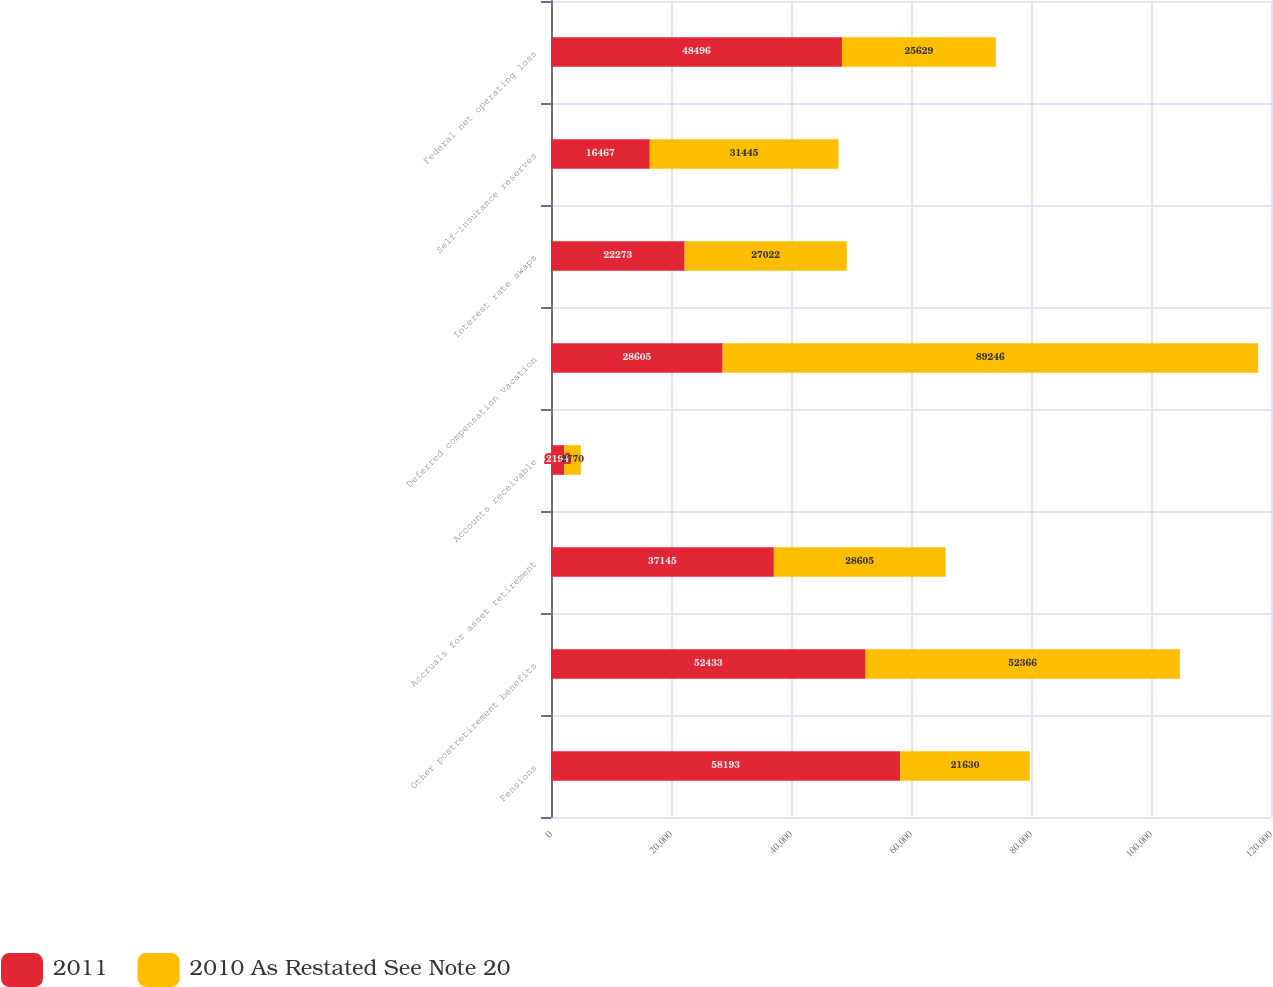<chart> <loc_0><loc_0><loc_500><loc_500><stacked_bar_chart><ecel><fcel>Pensions<fcel>Other postretirement benefits<fcel>Accruals for asset retirement<fcel>Accounts receivable<fcel>Deferred compensation vacation<fcel>Interest rate swaps<fcel>Self-insurance reserves<fcel>Federal net operating loss<nl><fcel>2011<fcel>58193<fcel>52433<fcel>37145<fcel>2194<fcel>28605<fcel>22273<fcel>16467<fcel>48496<nl><fcel>2010 As Restated See Note 20<fcel>21630<fcel>52366<fcel>28605<fcel>2770<fcel>89246<fcel>27022<fcel>31445<fcel>25629<nl></chart> 